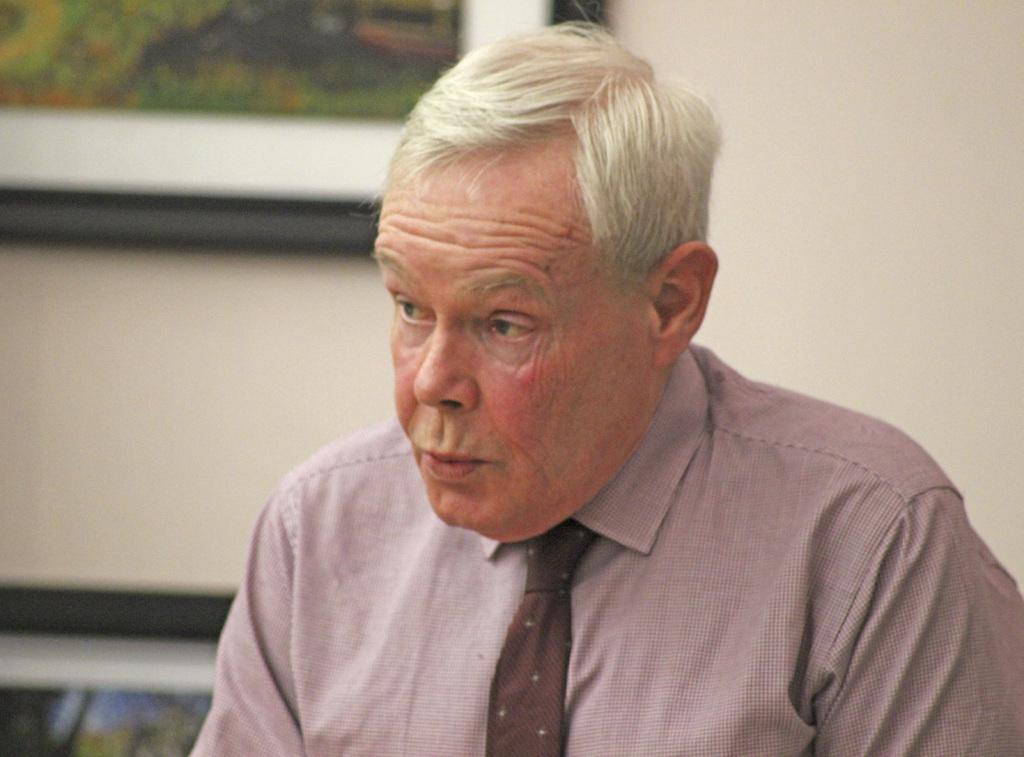What is the main subject of the image? There is a man in the image. What is the man wearing around his neck? The man is wearing a tie. What type of clothing is the man wearing on his upper body? The man is wearing a shirt. What can be seen on the wall in the background of the image? There are frames on the wall in the background of the image. What type of blade is the man holding in the image? There is no blade present in the image; the man is not holding any object. 